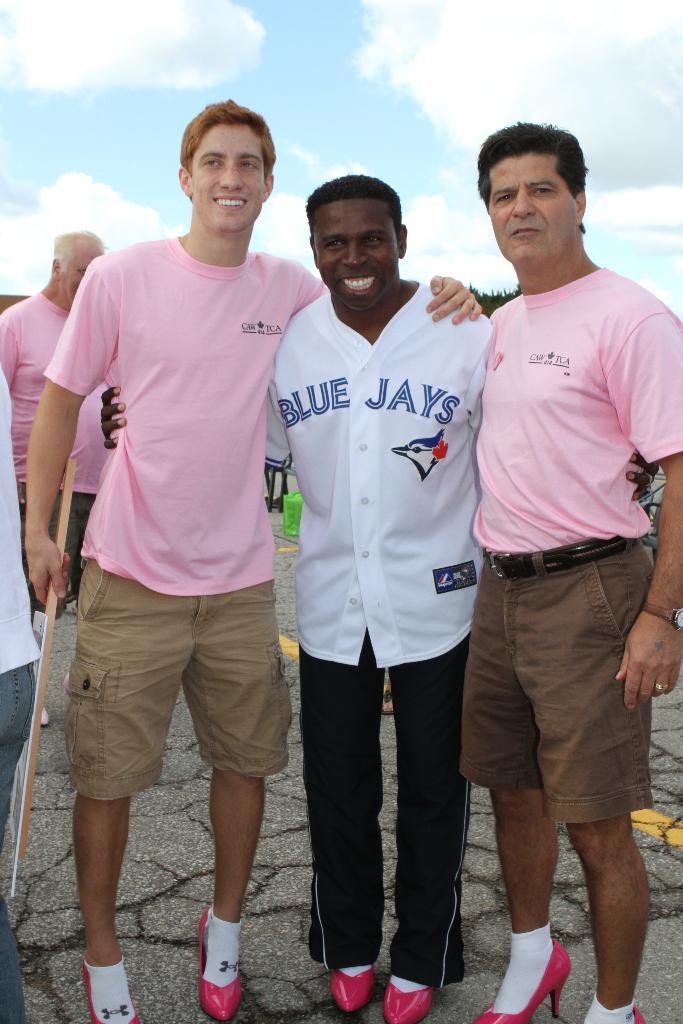Describe this image in one or two sentences. In the foreground of the picture there are three men standing. On the right the person is wearing pink t shirt. On the left the person is wearing pink t-shirt. In the center of the person is wearing a white shirt. On the left there are two people. Sky is partially cloudy. In the background there are trees and other objects. At the bottom it is road. 